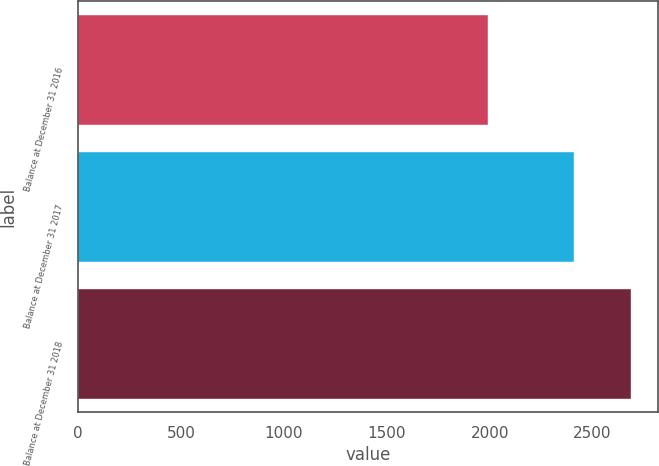<chart> <loc_0><loc_0><loc_500><loc_500><bar_chart><fcel>Balance at December 31 2016<fcel>Balance at December 31 2017<fcel>Balance at December 31 2018<nl><fcel>1992.7<fcel>2411.4<fcel>2685.7<nl></chart> 